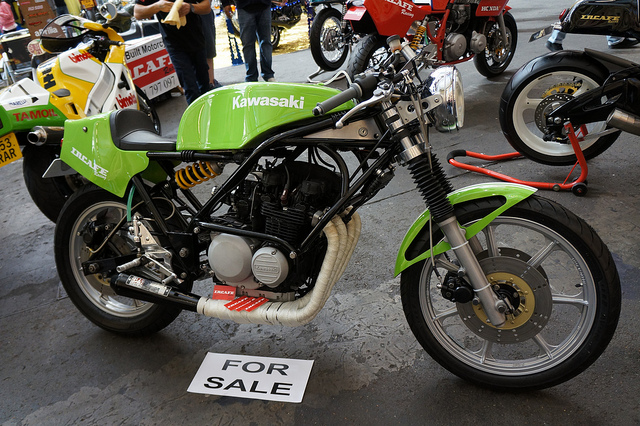Read and extract the text from this image. Kawasaki FOR SALE 797 CAF RAR 53 TAMOR 